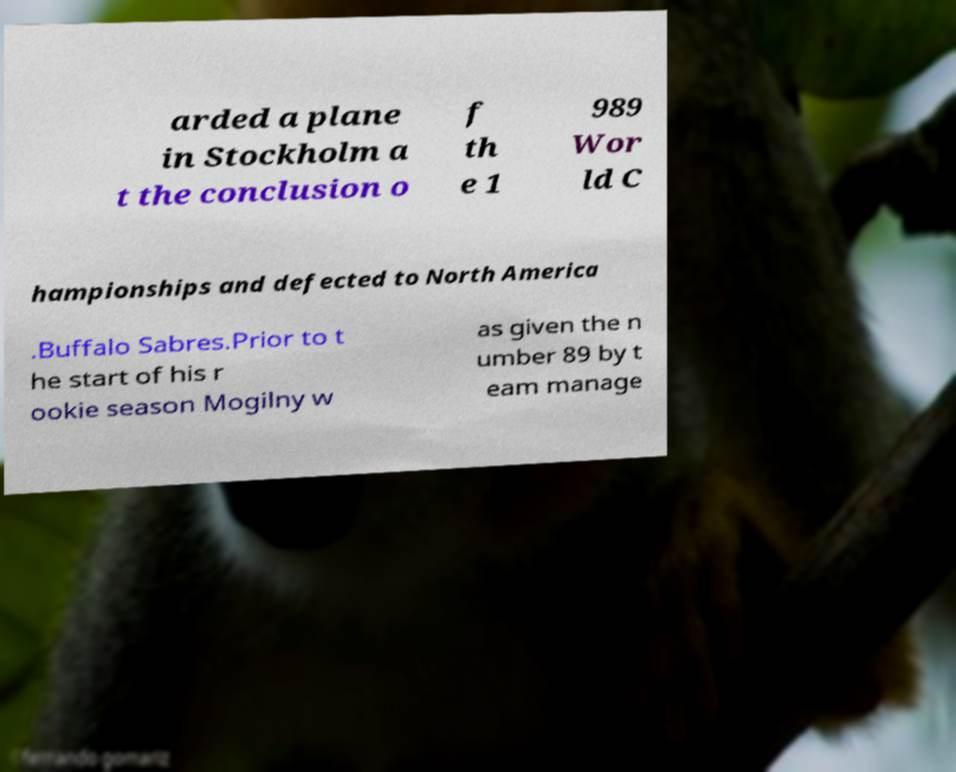Could you assist in decoding the text presented in this image and type it out clearly? arded a plane in Stockholm a t the conclusion o f th e 1 989 Wor ld C hampionships and defected to North America .Buffalo Sabres.Prior to t he start of his r ookie season Mogilny w as given the n umber 89 by t eam manage 